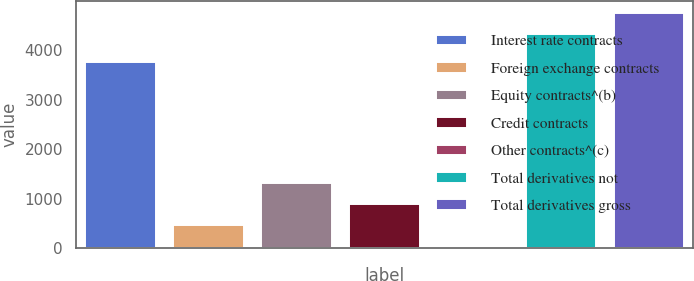<chart> <loc_0><loc_0><loc_500><loc_500><bar_chart><fcel>Interest rate contracts<fcel>Foreign exchange contracts<fcel>Equity contracts^(b)<fcel>Credit contracts<fcel>Other contracts^(c)<fcel>Total derivatives not<fcel>Total derivatives gross<nl><fcel>3771<fcel>463.2<fcel>1321.6<fcel>892.4<fcel>34<fcel>4326<fcel>4755.2<nl></chart> 